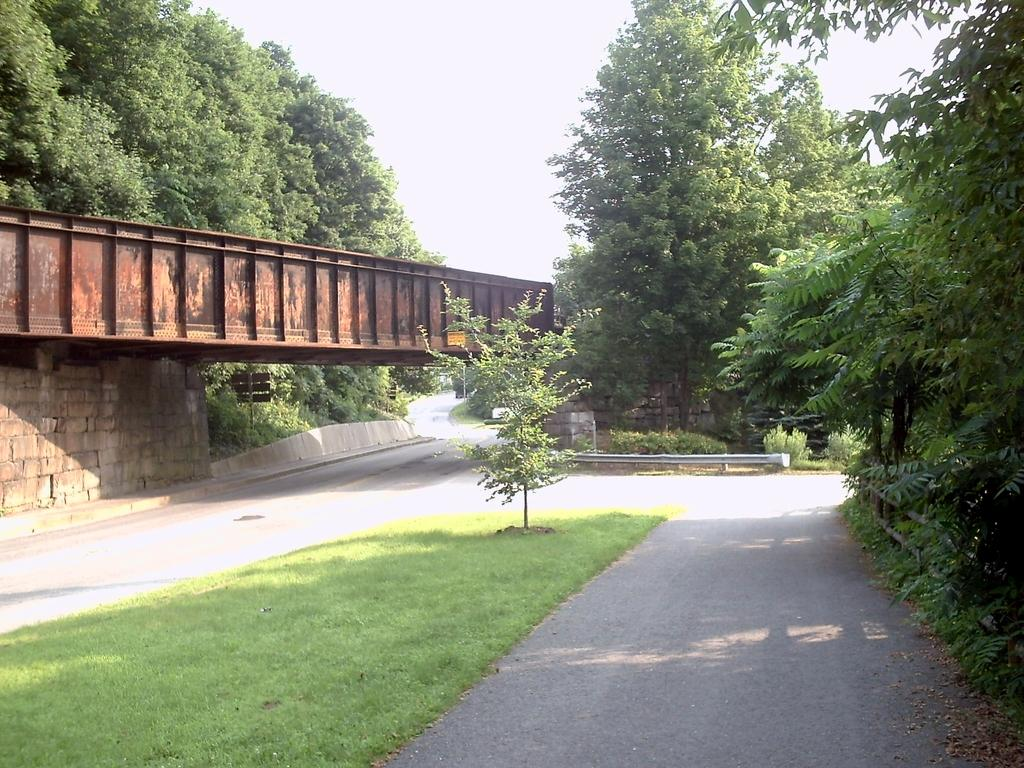What type of vegetation can be seen in the image? There are trees in the image. What structure is located on the left side of the image? There is a bridge on the left side of the image. What object is present in the image that might be used for support or signage? There is a pole in the image. What is visible at the top of the image? The sky is visible at the top of the image. What type of surface can be seen at the bottom of the image? There is a road at the bottom of the image. What type of ground cover is present in the image? There is grass in the image. What type of song is being sung by the trees in the image? There are no trees singing in the image; they are stationary plants. What type of insurance is being offered by the bridge in the image? There is no insurance being offered by the bridge in the image; it is a structure for crossing over a body of water. 